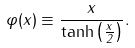<formula> <loc_0><loc_0><loc_500><loc_500>\varphi ( x ) \equiv \frac { x } { \tanh \left ( \frac { x } { 2 } \right ) } .</formula> 